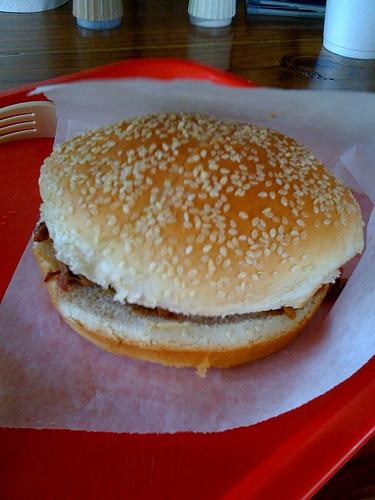What is on top of the bun? sesame seeds 